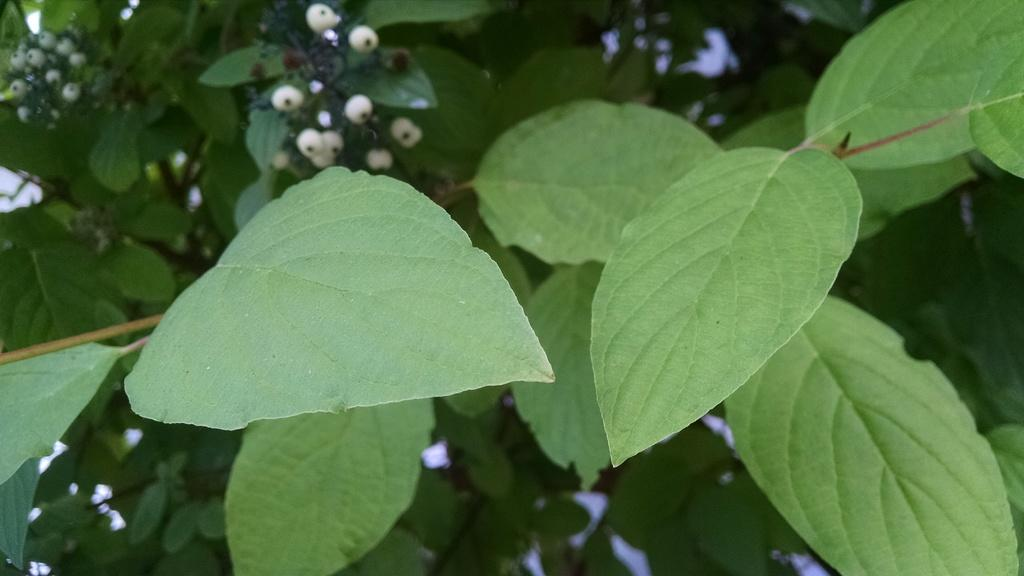What color are the leaves in the image? The leaves in the image are green. What type of education is being provided in the image? There is no indication of education in the image, as it only features green color leaves. Is there a garden visible in the image? The provided facts do not mention a garden, and the image only shows green color leaves. 